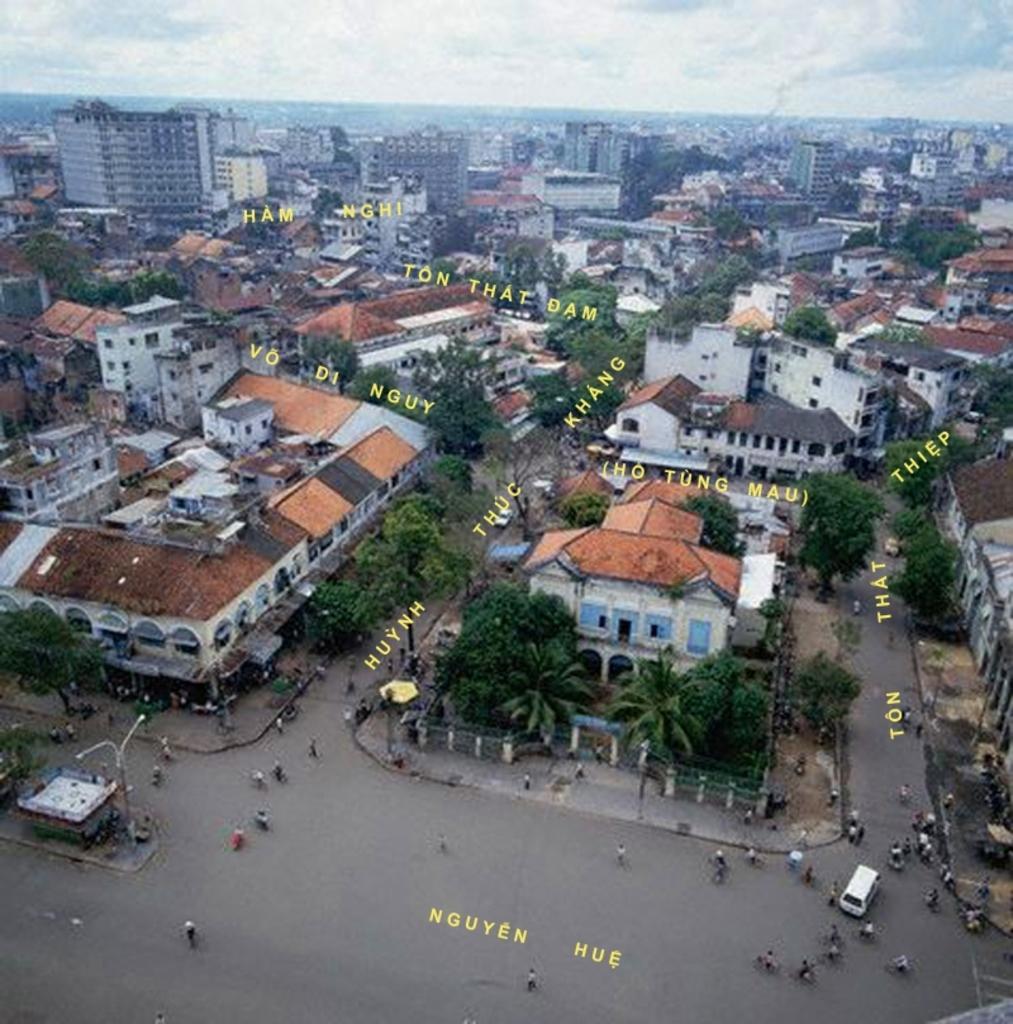Please provide a concise description of this image. In the image there are so many buildings, trees and people on the road also there is a some text. 